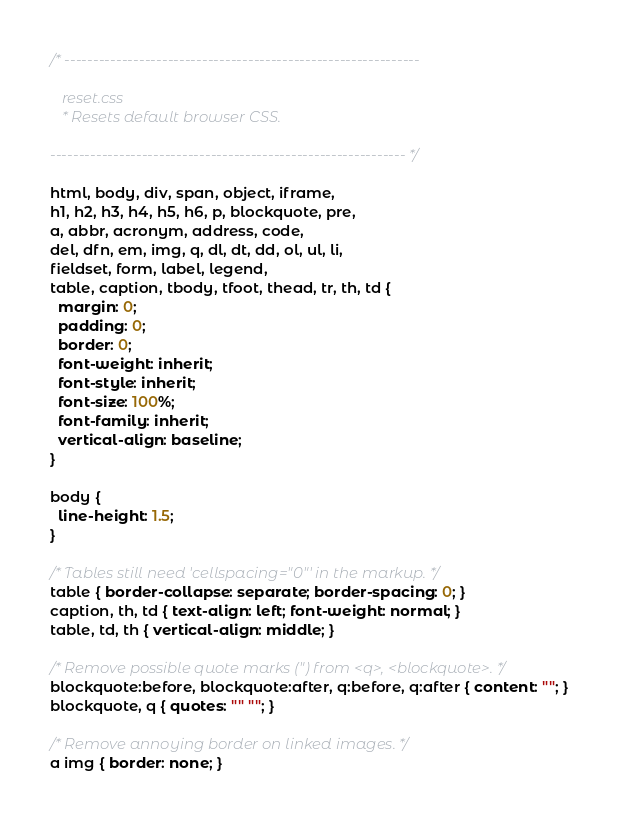<code> <loc_0><loc_0><loc_500><loc_500><_CSS_>/* -------------------------------------------------------------- 
  
   reset.css
   * Resets default browser CSS.
   
-------------------------------------------------------------- */

html, body, div, span, object, iframe,
h1, h2, h3, h4, h5, h6, p, blockquote, pre,
a, abbr, acronym, address, code,
del, dfn, em, img, q, dl, dt, dd, ol, ul, li,
fieldset, form, label, legend,
table, caption, tbody, tfoot, thead, tr, th, td {
  margin: 0;
  padding: 0;
  border: 0;
  font-weight: inherit;
  font-style: inherit;
  font-size: 100%;
  font-family: inherit;
  vertical-align: baseline;
}

body { 
  line-height: 1.5; 
}

/* Tables still need 'cellspacing="0"' in the markup. */
table { border-collapse: separate; border-spacing: 0; }
caption, th, td { text-align: left; font-weight: normal; }
table, td, th { vertical-align: middle; }

/* Remove possible quote marks (") from <q>, <blockquote>. */
blockquote:before, blockquote:after, q:before, q:after { content: ""; }
blockquote, q { quotes: "" ""; }

/* Remove annoying border on linked images. */
a img { border: none; }
</code> 